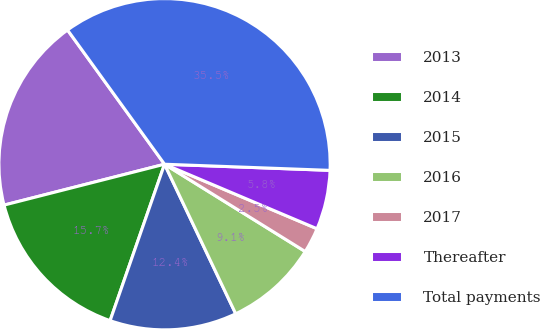Convert chart. <chart><loc_0><loc_0><loc_500><loc_500><pie_chart><fcel>2013<fcel>2014<fcel>2015<fcel>2016<fcel>2017<fcel>Thereafter<fcel>Total payments<nl><fcel>19.01%<fcel>15.7%<fcel>12.4%<fcel>9.09%<fcel>2.47%<fcel>5.78%<fcel>35.55%<nl></chart> 